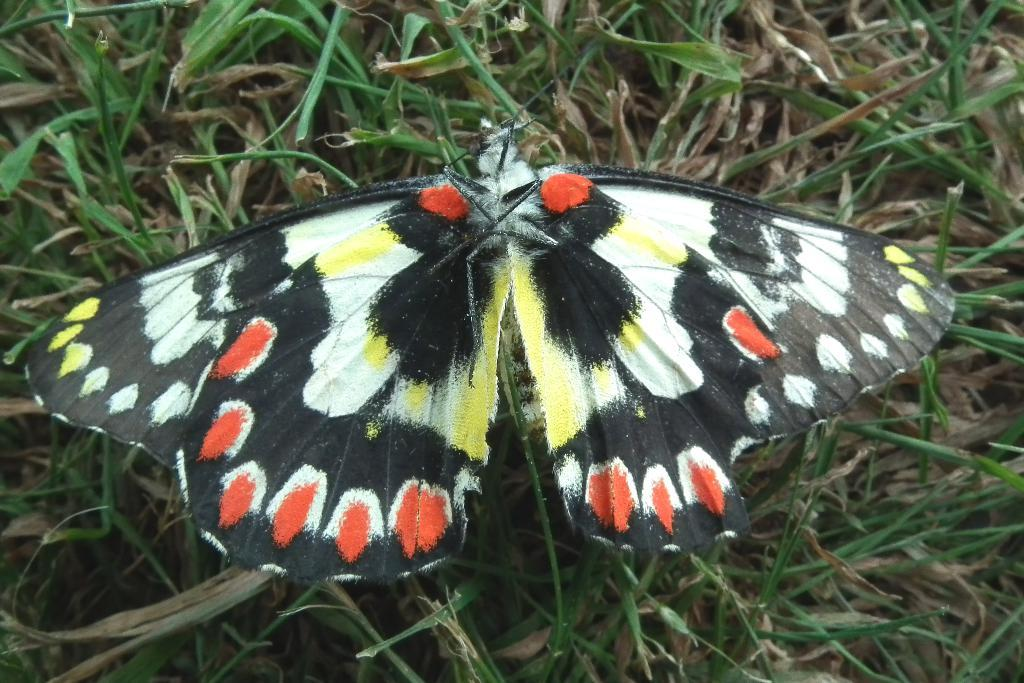What is the main subject of the image? There is a butterfly in the image. Where is the butterfly located? The butterfly is on the grass. What thoughts does the butterfly have about the thread in the image? There is no thread present in the image, and butterflies do not have thoughts like humans. 